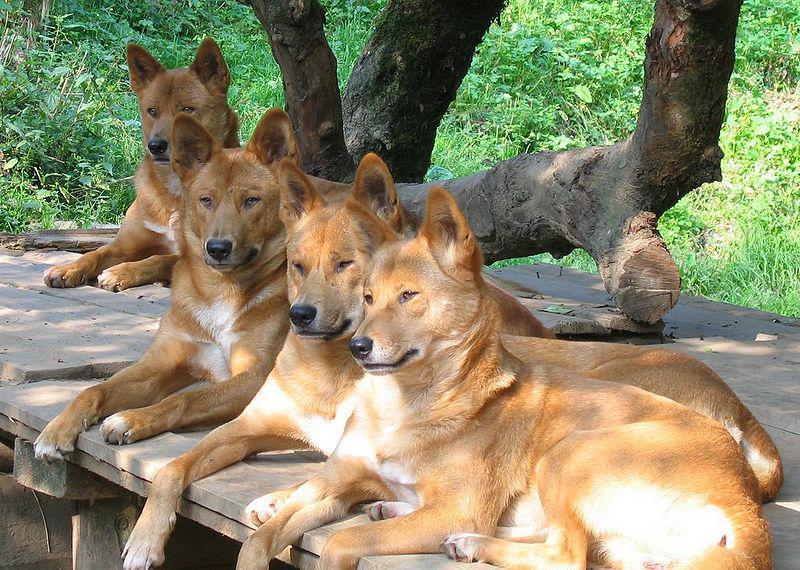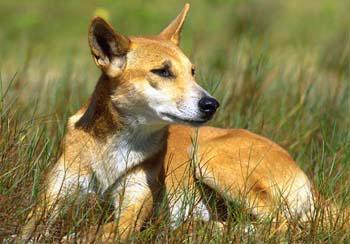The first image is the image on the left, the second image is the image on the right. Assess this claim about the two images: "There are at most three dingoes.". Correct or not? Answer yes or no. No. The first image is the image on the left, the second image is the image on the right. For the images displayed, is the sentence "The combined images contain five dingos, and at least one dingo is reclining." factually correct? Answer yes or no. Yes. 